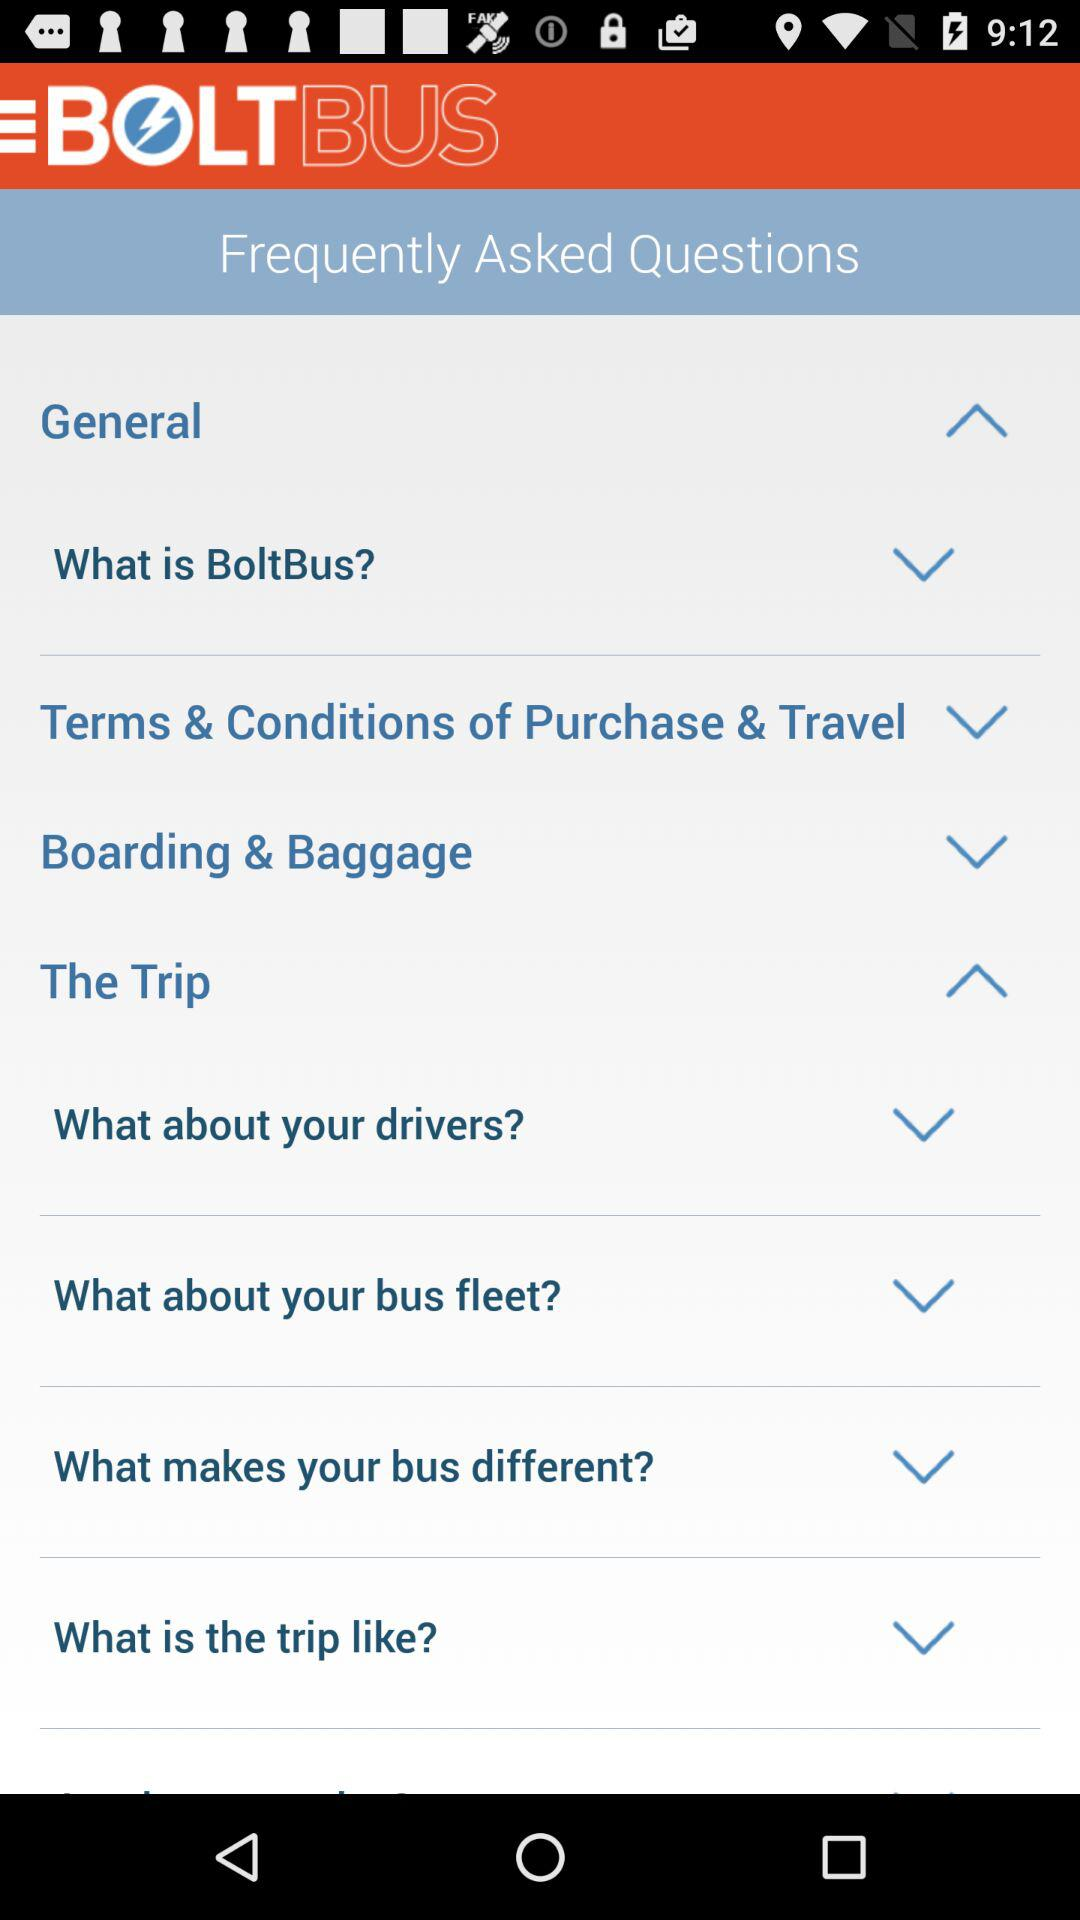What is the name of the application? The name of the application is "BOLTBUS". 